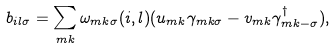<formula> <loc_0><loc_0><loc_500><loc_500>b _ { i l \sigma } = \sum _ { m k } \omega _ { m k \sigma } ( i , l ) ( u _ { m k } \gamma _ { m k \sigma } - v _ { m k } \gamma _ { m k - \sigma } ^ { \dagger } ) ,</formula> 